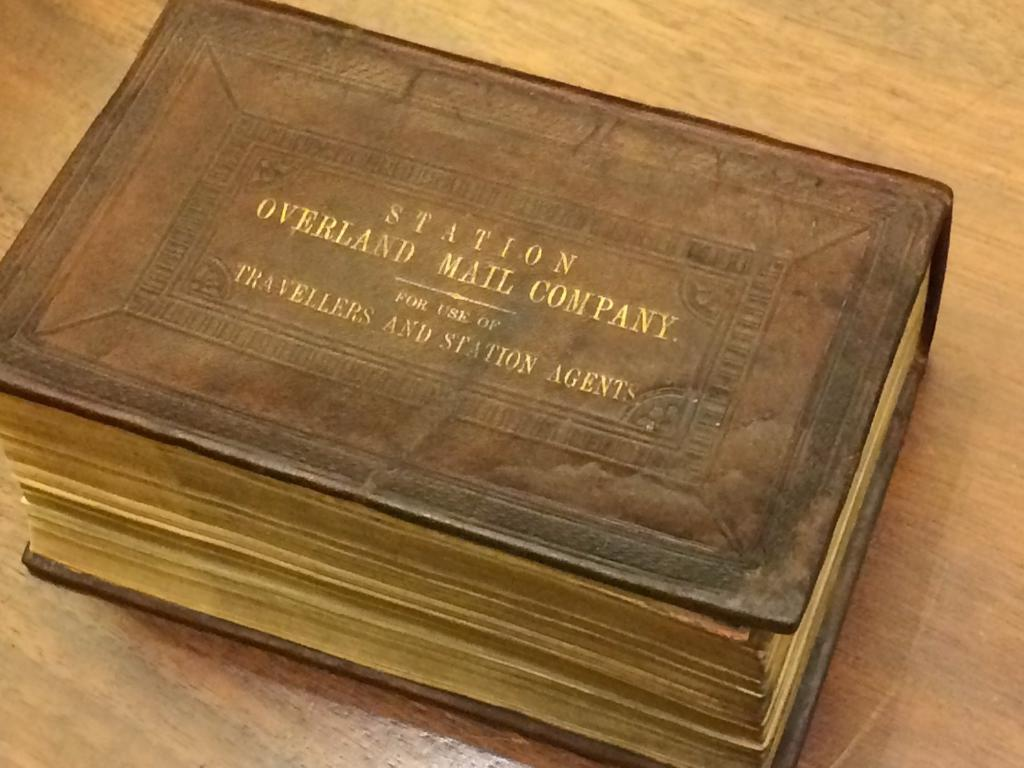<image>
Relay a brief, clear account of the picture shown. An old looking brown book with the word sTATION ON THE TOP 